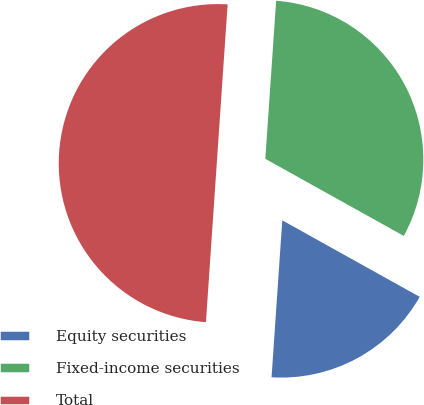Convert chart. <chart><loc_0><loc_0><loc_500><loc_500><pie_chart><fcel>Equity securities<fcel>Fixed-income securities<fcel>Total<nl><fcel>18.0%<fcel>32.0%<fcel>50.0%<nl></chart> 